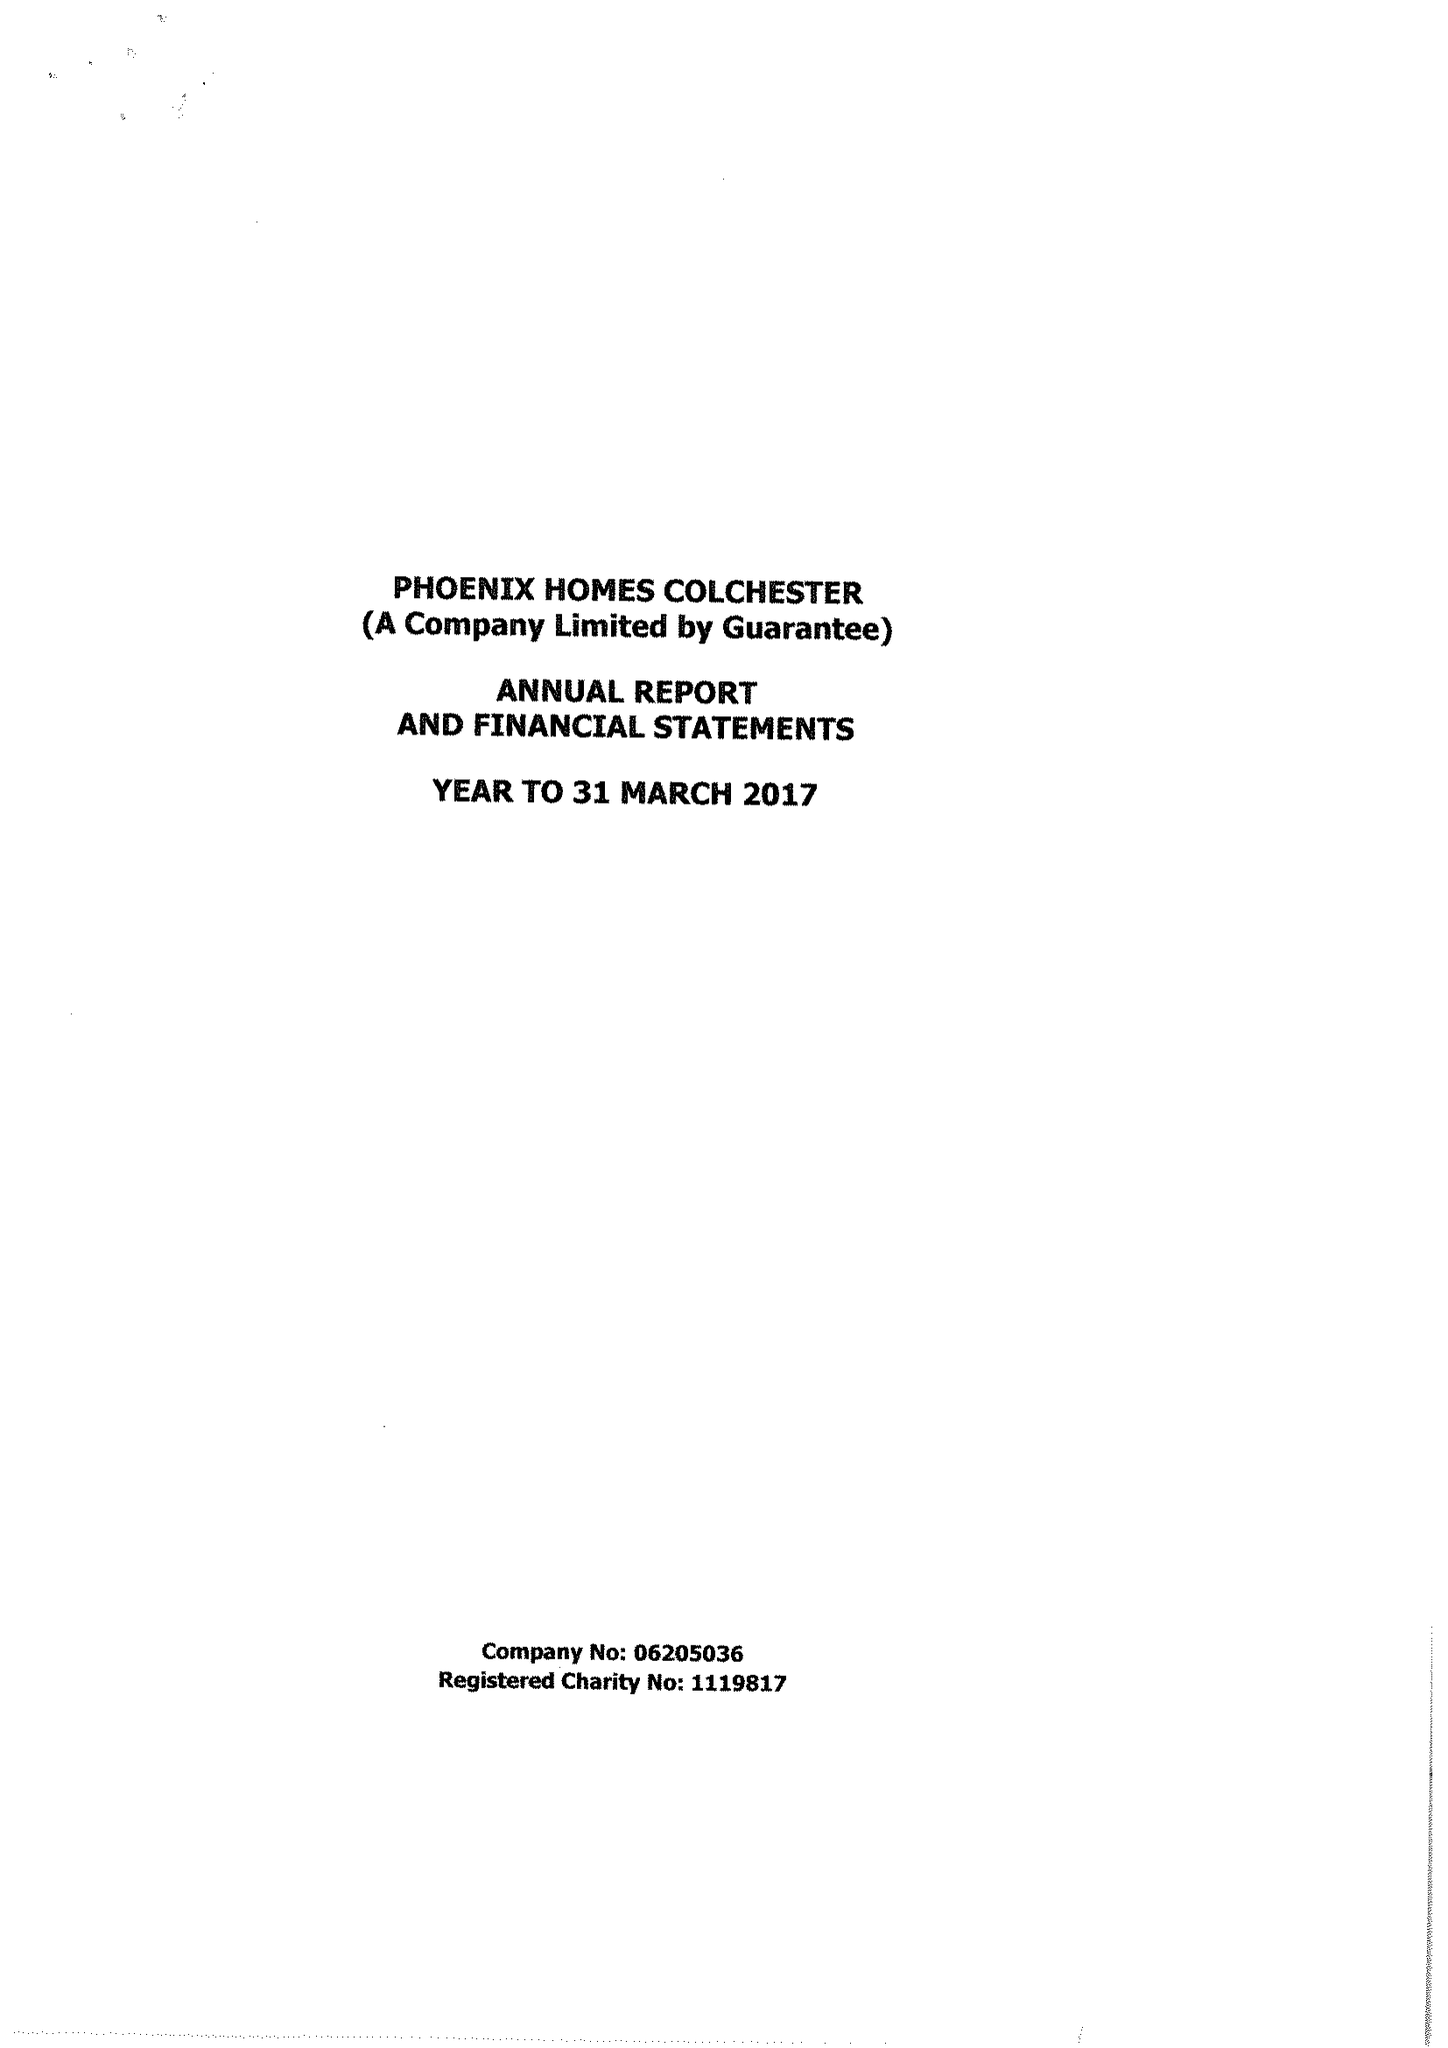What is the value for the charity_name?
Answer the question using a single word or phrase. Phoenix Homes Colchester 